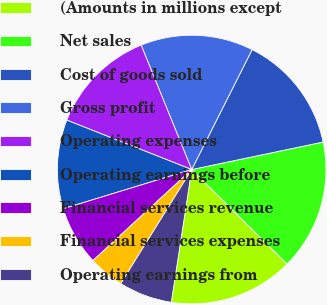<chart> <loc_0><loc_0><loc_500><loc_500><pie_chart><fcel>(Amounts in millions except<fcel>Net sales<fcel>Cost of goods sold<fcel>Gross profit<fcel>Operating expenses<fcel>Operating earnings before<fcel>Financial services revenue<fcel>Financial services expenses<fcel>Operating earnings from<nl><fcel>15.0%<fcel>15.71%<fcel>14.29%<fcel>13.57%<fcel>12.86%<fcel>10.71%<fcel>7.14%<fcel>4.29%<fcel>6.43%<nl></chart> 